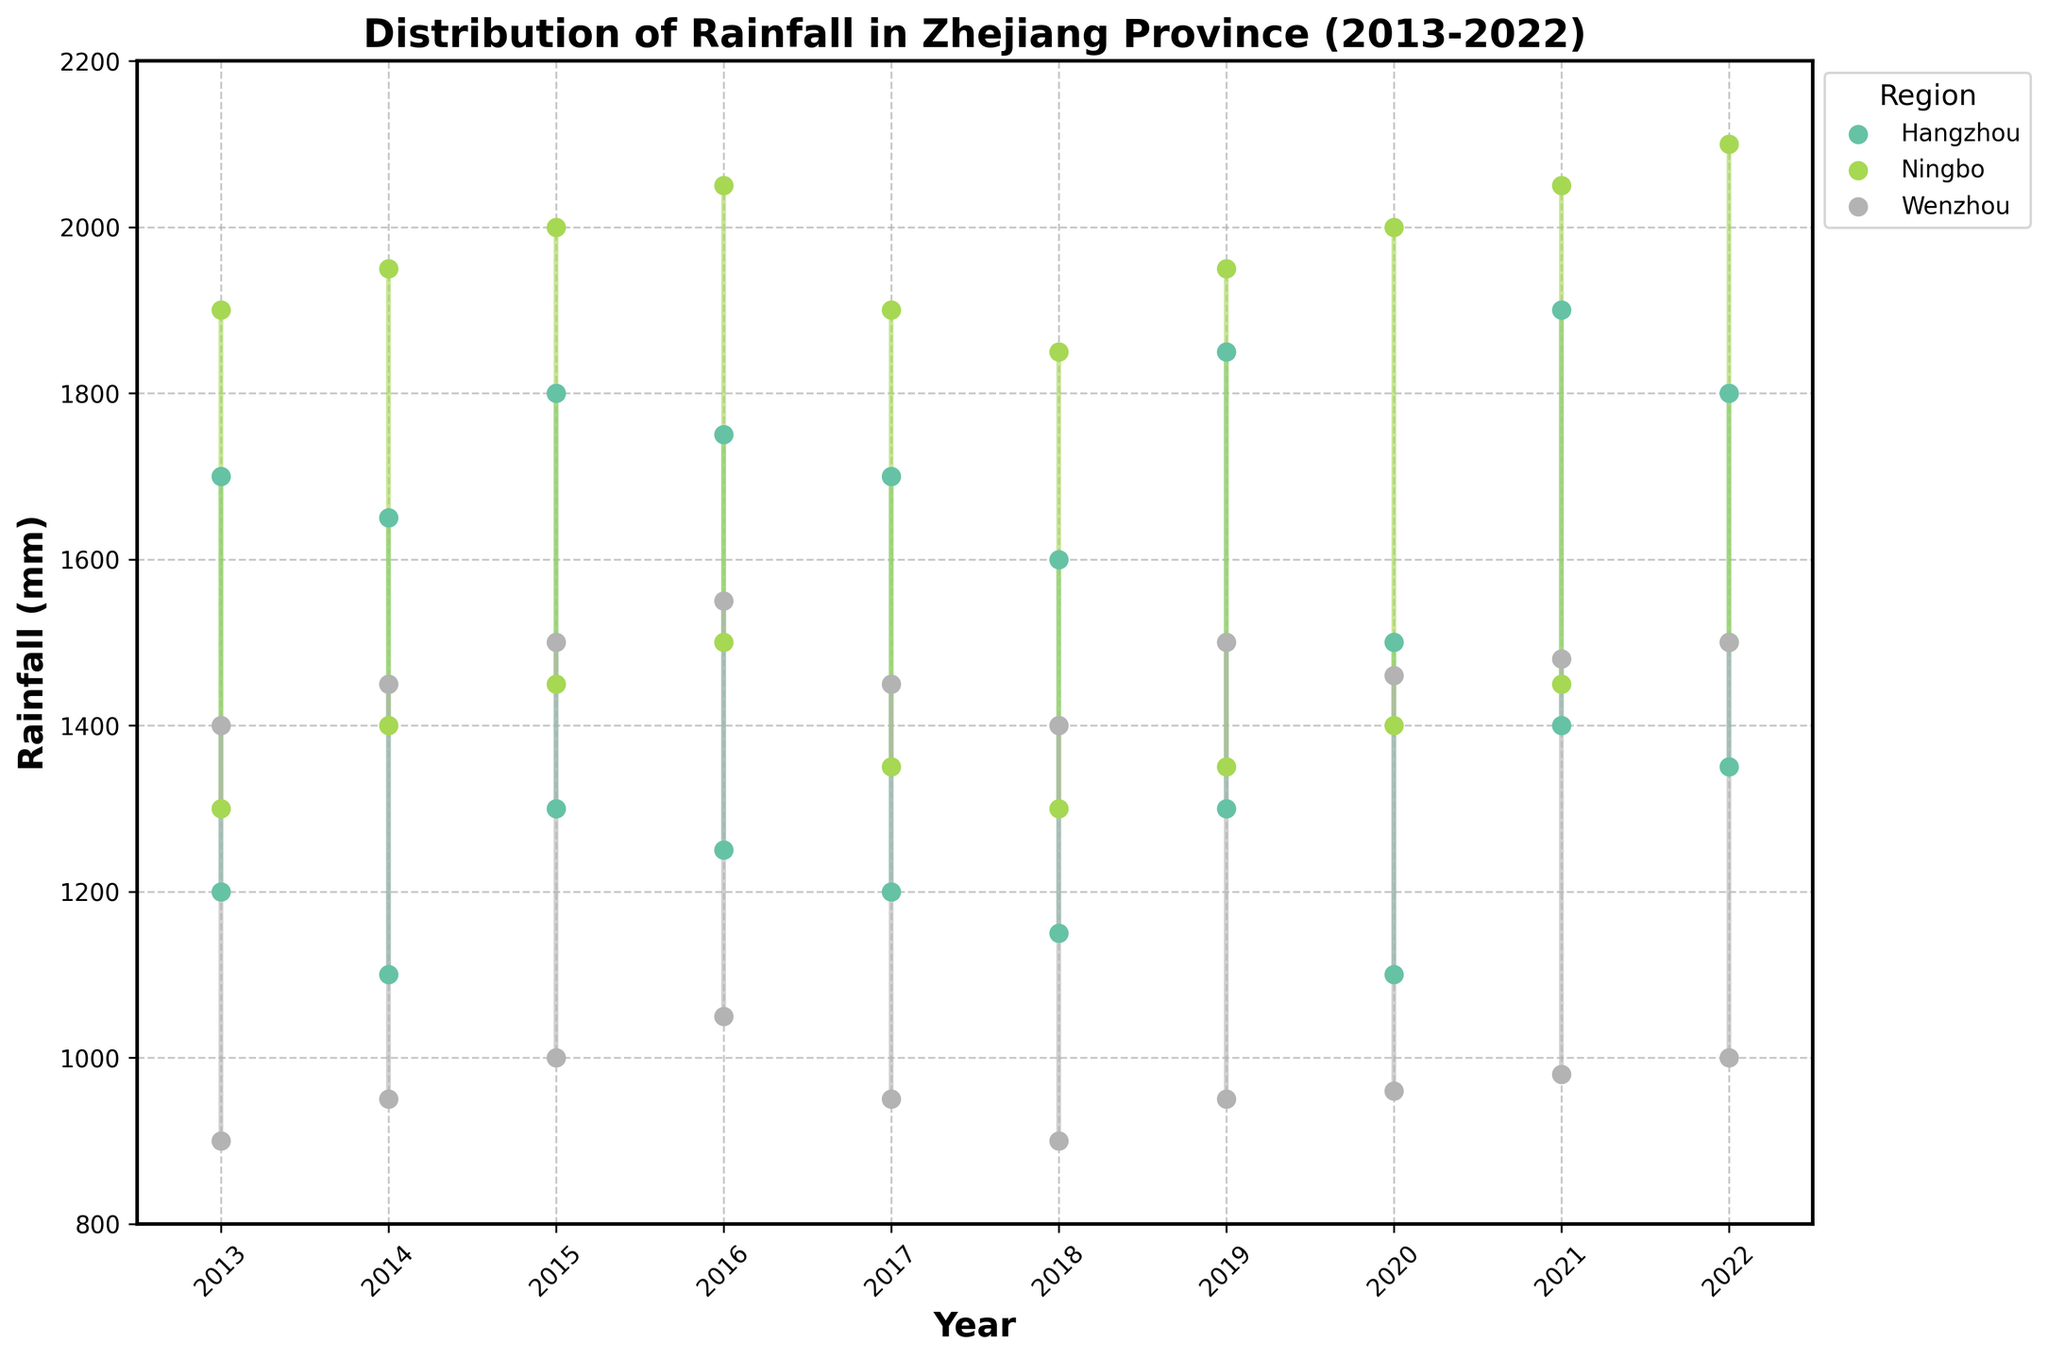What is the title of the plot? The title is the name displayed at the top of the plot. Here, the title is "Distribution of Rainfall in Zhejiang Province (2013-2022)."
Answer: Distribution of Rainfall in Zhejiang Province (2013-2022) Which region has the highest maximum rainfall in 2022? To find this, locate the year 2022 on the x-axis and look for the highest maximum rainfall value on the y-axis that corresponds to one of the regions. The highest maximum rainfall in 2022 is for Ningbo at 2100 mm.
Answer: Ningbo What is the average minimum rainfall in Wenzhou for the given years? Find the minimum rainfall for Wenzhou from 2013 to 2022 and calculate their average. The values are (900, 950, 1000, 1050, 950, 900, 950, 960, 980, 1000). Sum them up (900+950+1000+1050+950+900+950+960+980+1000) = 9640. Divide by 10 (years) to get the average: 9640/10 = 964 mm.
Answer: 964 mm Compare the range of rainfall for Hangzhou and Ningbo in 2017. Which region had a broader range? To determine the range of rainfall, subtract the minimum rainfall value from the maximum rainfall value for each region. For Hangzhou: 1700 - 1200 = 500 mm, and for Ningbo: 1900 - 1350 = 550 mm. Ningbo had a broader range.
Answer: Ningbo Did any region experience a consistent increase in maximum rainfall over the decade? Check each region's maximum rainfall values from 2013 to 2022. A consistent increase means each subsequent year has a higher maximum rainfall than the previous. None of the regions show a consistent increase over the entire decade.
Answer: No What was the minimum rainfall in Ningbo in 2016? Find the point for Ningbo in 2016 and locate the minimum rainfall value on the y-axis. The minimum rainfall for Ningbo in 2016 is 1500 mm.
Answer: 1500 mm Which year had the least variability in rainfall for Wenzhou? Variability is determined by the difference between max and min rainfall. Calculate the difference for each year for Wenzhou. The year with the smallest difference indicates the least variability. For Wenzhou, 2020 had the least variability: 1460 - 960 = 500 mm.
Answer: 2020 What trend can you observe in Hangzhou's minimum rainfall over the years? Observe the data points of minimum rainfall for Hangzhou from 2013 to 2022. The minimum rainfall varies but doesn't show a clear increasing or decreasing trend overall.
Answer: No clear trend What is the difference in maximum rainfall between Ningbo and Wenzhou in 2019? Find the maximum rainfall for Ningbo and Wenzhou in 2019. For Ningbo: 1950 mm, and for Wenzhou: 1500 mm. The difference is 1950 - 1500 = 450 mm.
Answer: 450 mm Which region had the highest minimum rainfall in any single year? Look for the highest minimum rainfall point across all years and all regions. The highest minimum rainfall is in Ningbo in 2022 at 1500 mm.
Answer: Ningbo 